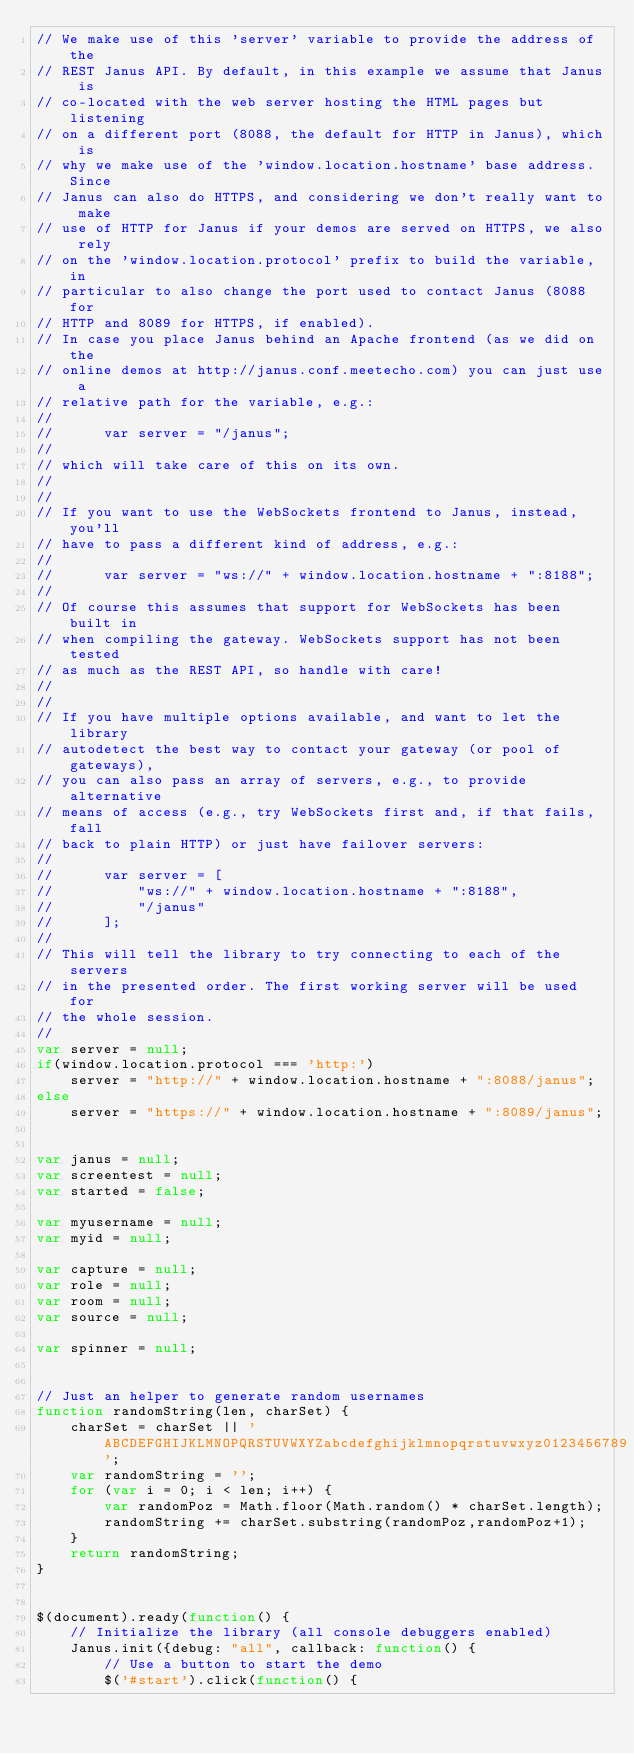<code> <loc_0><loc_0><loc_500><loc_500><_JavaScript_>// We make use of this 'server' variable to provide the address of the
// REST Janus API. By default, in this example we assume that Janus is
// co-located with the web server hosting the HTML pages but listening
// on a different port (8088, the default for HTTP in Janus), which is
// why we make use of the 'window.location.hostname' base address. Since
// Janus can also do HTTPS, and considering we don't really want to make
// use of HTTP for Janus if your demos are served on HTTPS, we also rely
// on the 'window.location.protocol' prefix to build the variable, in
// particular to also change the port used to contact Janus (8088 for
// HTTP and 8089 for HTTPS, if enabled).
// In case you place Janus behind an Apache frontend (as we did on the
// online demos at http://janus.conf.meetecho.com) you can just use a
// relative path for the variable, e.g.:
//
// 		var server = "/janus";
//
// which will take care of this on its own.
//
//
// If you want to use the WebSockets frontend to Janus, instead, you'll
// have to pass a different kind of address, e.g.:
//
// 		var server = "ws://" + window.location.hostname + ":8188";
//
// Of course this assumes that support for WebSockets has been built in
// when compiling the gateway. WebSockets support has not been tested
// as much as the REST API, so handle with care!
//
//
// If you have multiple options available, and want to let the library
// autodetect the best way to contact your gateway (or pool of gateways),
// you can also pass an array of servers, e.g., to provide alternative
// means of access (e.g., try WebSockets first and, if that fails, fall
// back to plain HTTP) or just have failover servers:
//
//		var server = [
//			"ws://" + window.location.hostname + ":8188",
//			"/janus"
//		];
//
// This will tell the library to try connecting to each of the servers
// in the presented order. The first working server will be used for
// the whole session.
//
var server = null;
if(window.location.protocol === 'http:')
	server = "http://" + window.location.hostname + ":8088/janus";
else
	server = "https://" + window.location.hostname + ":8089/janus";


var janus = null;
var screentest = null;
var started = false;

var myusername = null;
var myid = null;

var capture = null;
var role = null;
var room = null;
var source = null;

var spinner = null;


// Just an helper to generate random usernames
function randomString(len, charSet) {
    charSet = charSet || 'ABCDEFGHIJKLMNOPQRSTUVWXYZabcdefghijklmnopqrstuvwxyz0123456789';
    var randomString = '';
    for (var i = 0; i < len; i++) {
    	var randomPoz = Math.floor(Math.random() * charSet.length);
    	randomString += charSet.substring(randomPoz,randomPoz+1);
    }
    return randomString;
}


$(document).ready(function() {
	// Initialize the library (all console debuggers enabled)
	Janus.init({debug: "all", callback: function() {
		// Use a button to start the demo
		$('#start').click(function() {</code> 